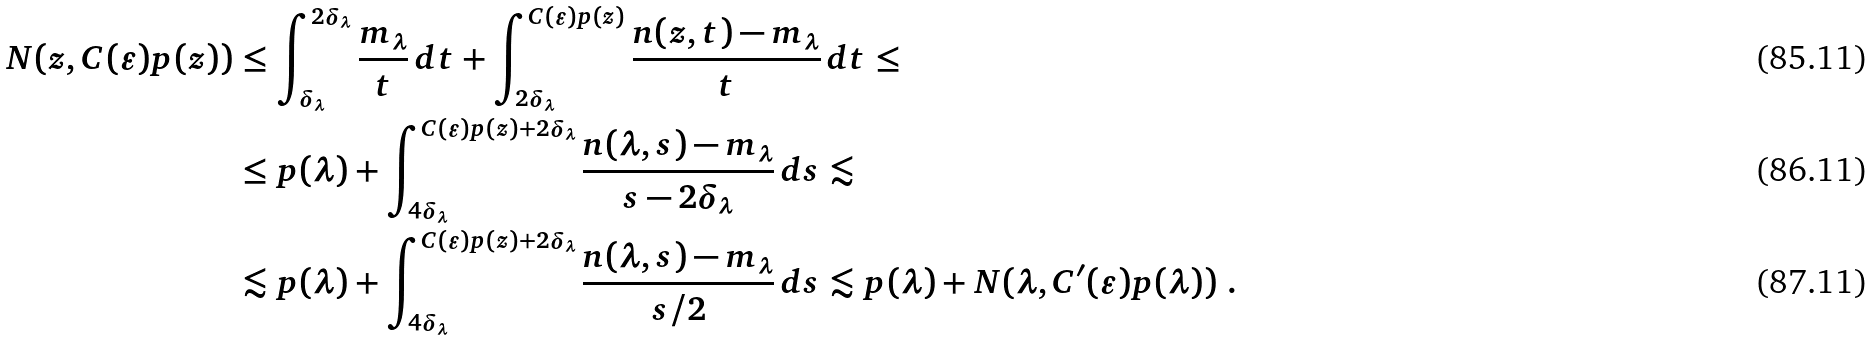Convert formula to latex. <formula><loc_0><loc_0><loc_500><loc_500>N ( z , C ( \varepsilon ) p ( z ) ) & \leq \int _ { \delta _ { \lambda } } ^ { 2 \delta _ { \lambda } } \frac { m _ { \lambda } } t \, d t + \int _ { 2 \delta _ { \lambda } } ^ { C ( \varepsilon ) p ( z ) } \frac { n ( z , t ) - m _ { \lambda } } t \, d t \leq \\ & \leq p ( \lambda ) + \int _ { 4 \delta _ { \lambda } } ^ { C ( \varepsilon ) p ( z ) + 2 \delta _ { \lambda } } \frac { n ( \lambda , s ) - m _ { \lambda } } { s - 2 \delta _ { \lambda } } \, d s \lesssim \\ & \lesssim p ( \lambda ) + \int _ { 4 \delta _ { \lambda } } ^ { C ( \varepsilon ) p ( z ) + 2 \delta _ { \lambda } } \frac { n ( \lambda , s ) - m _ { \lambda } } { s / 2 } \, d s \lesssim p ( \lambda ) + N ( \lambda , C ^ { \prime } ( \varepsilon ) p ( \lambda ) ) \ .</formula> 